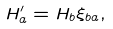Convert formula to latex. <formula><loc_0><loc_0><loc_500><loc_500>H _ { a } ^ { \prime } = H _ { b } \xi _ { b a } ,</formula> 